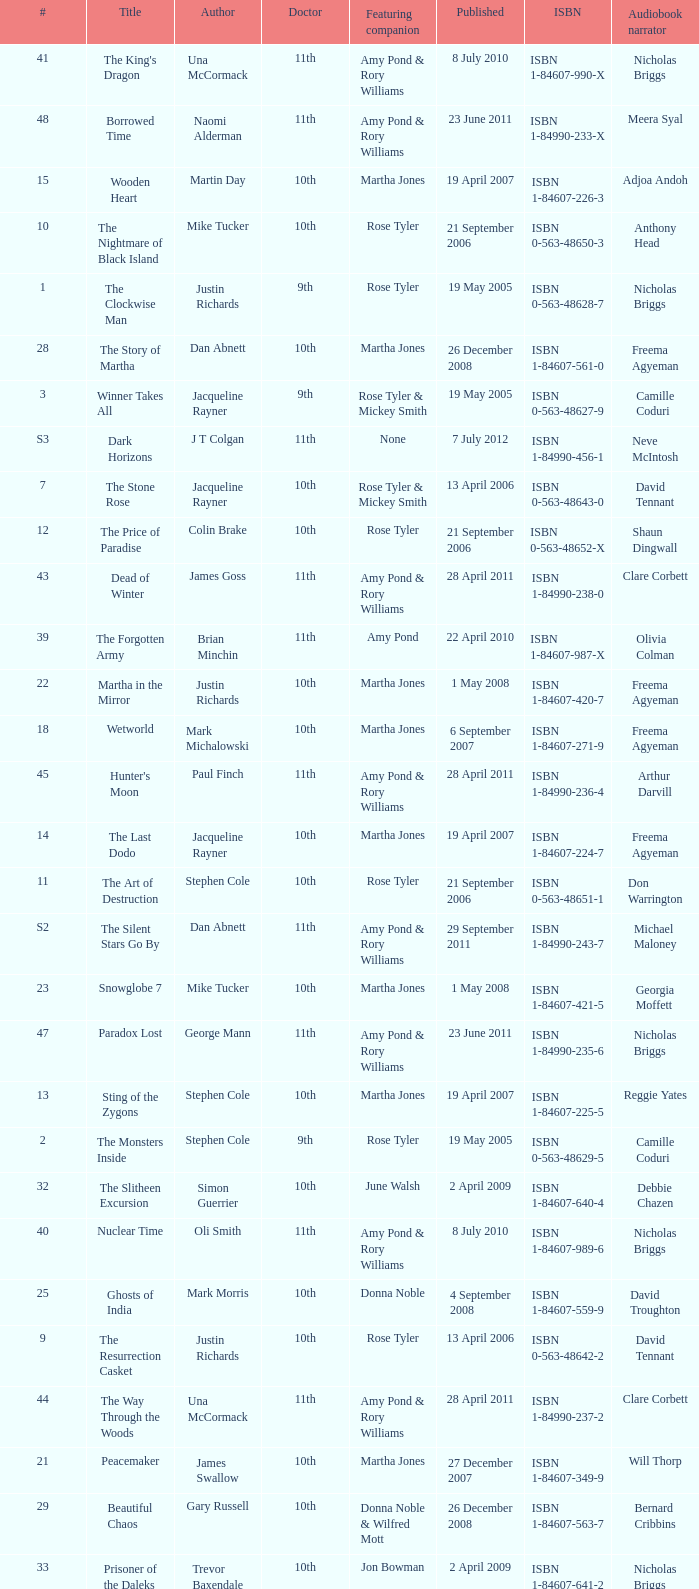Who are the featuring companions of number 3? Rose Tyler & Mickey Smith. 